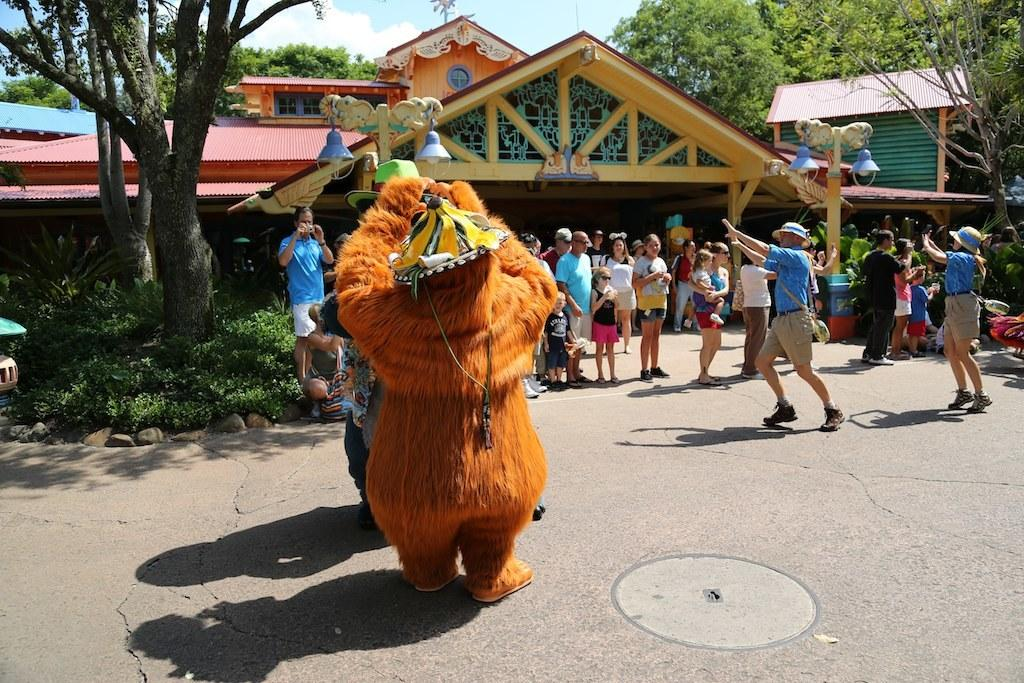What type of character can be seen in the image? There is a mascot in the image. Who else is present in the image besides the mascot? There is a group of people standing in the image. What structures can be seen in the image? There are buildings in the image. What type of vegetation is present in the image? There are plants and trees in the image. What is visible in the background of the image? The sky is visible in the background of the image. How many giraffes are present in the image? There are no giraffes present in the image. What type of paper is being used by the mascot in the image? There is no paper visible in the image. 